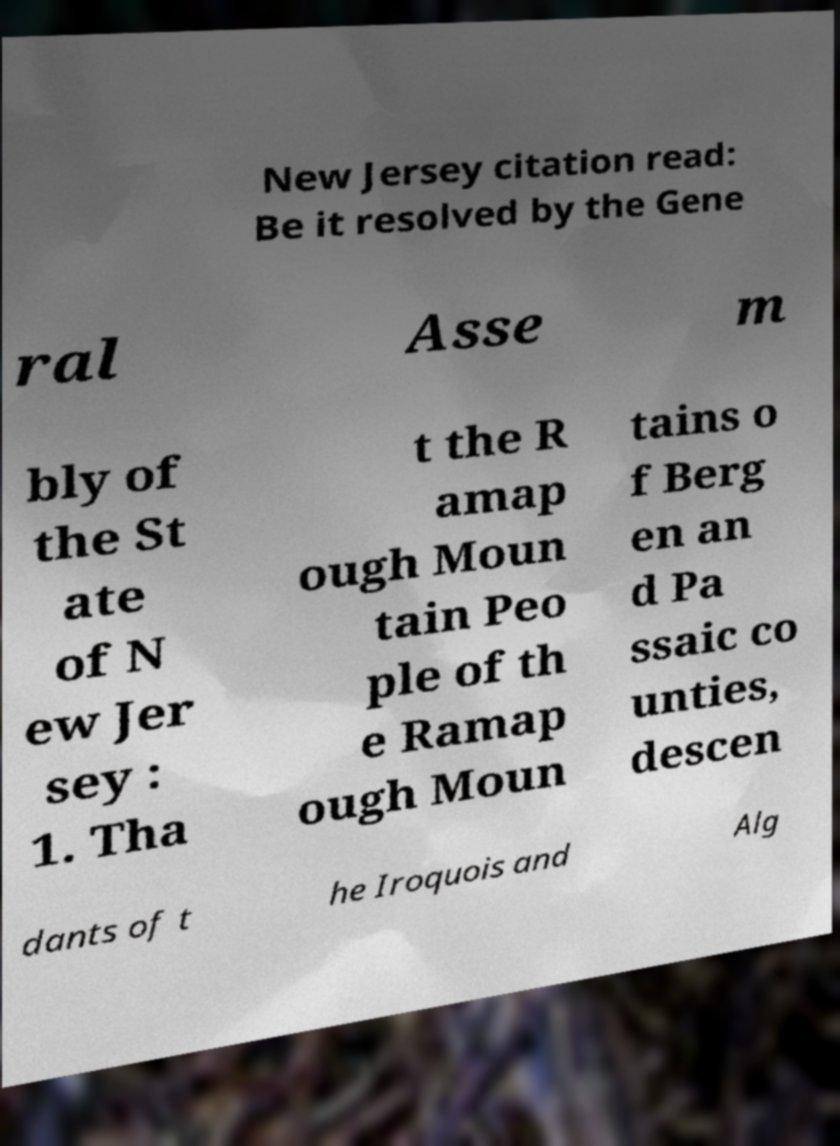Please read and relay the text visible in this image. What does it say? New Jersey citation read: Be it resolved by the Gene ral Asse m bly of the St ate of N ew Jer sey : 1. Tha t the R amap ough Moun tain Peo ple of th e Ramap ough Moun tains o f Berg en an d Pa ssaic co unties, descen dants of t he Iroquois and Alg 